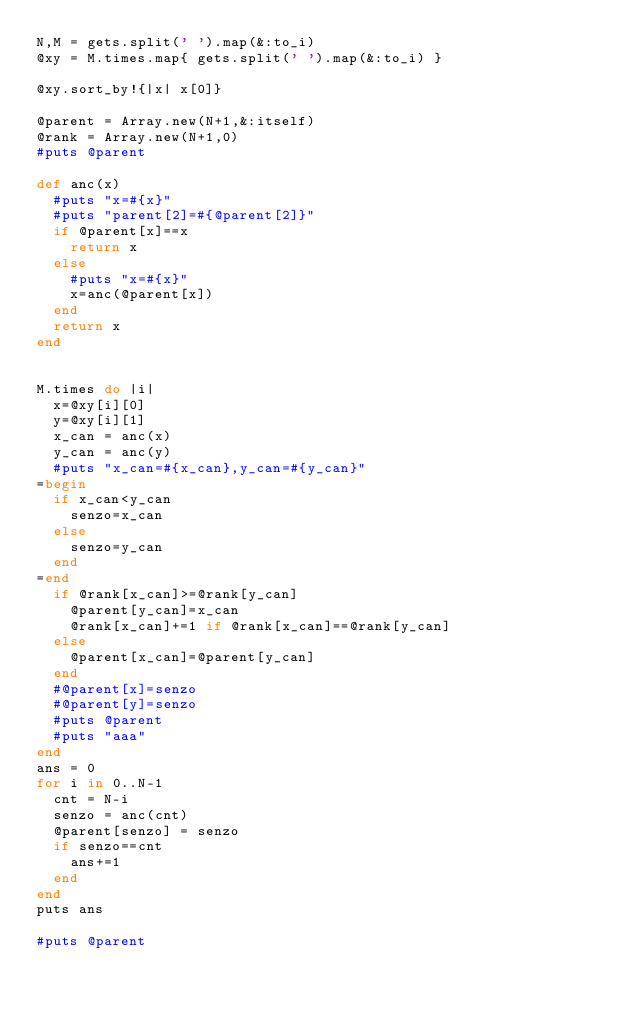<code> <loc_0><loc_0><loc_500><loc_500><_Ruby_>N,M = gets.split(' ').map(&:to_i)
@xy = M.times.map{ gets.split(' ').map(&:to_i) }

@xy.sort_by!{|x| x[0]}

@parent = Array.new(N+1,&:itself)
@rank = Array.new(N+1,0)
#puts @parent

def anc(x)
  #puts "x=#{x}"
  #puts "parent[2]=#{@parent[2]}"
  if @parent[x]==x
    return x
  else
    #puts "x=#{x}"
    x=anc(@parent[x])
  end
  return x
end


M.times do |i|
  x=@xy[i][0]
  y=@xy[i][1]
  x_can = anc(x)
  y_can = anc(y)
  #puts "x_can=#{x_can},y_can=#{y_can}"
=begin
  if x_can<y_can
    senzo=x_can
  else
    senzo=y_can
  end
=end
  if @rank[x_can]>=@rank[y_can]
    @parent[y_can]=x_can
    @rank[x_can]+=1 if @rank[x_can]==@rank[y_can]
  else
    @parent[x_can]=@parent[y_can]
  end
  #@parent[x]=senzo
  #@parent[y]=senzo
  #puts @parent
  #puts "aaa"
end
ans = 0
for i in 0..N-1
  cnt = N-i
  senzo = anc(cnt)
  @parent[senzo] = senzo
  if senzo==cnt
    ans+=1
  end
end
puts ans

#puts @parent
</code> 